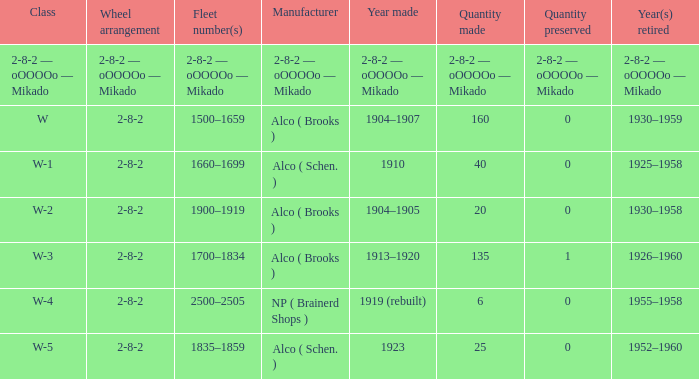What is the year retired of the locomotive which had the quantity made of 25? 1952–1960. 